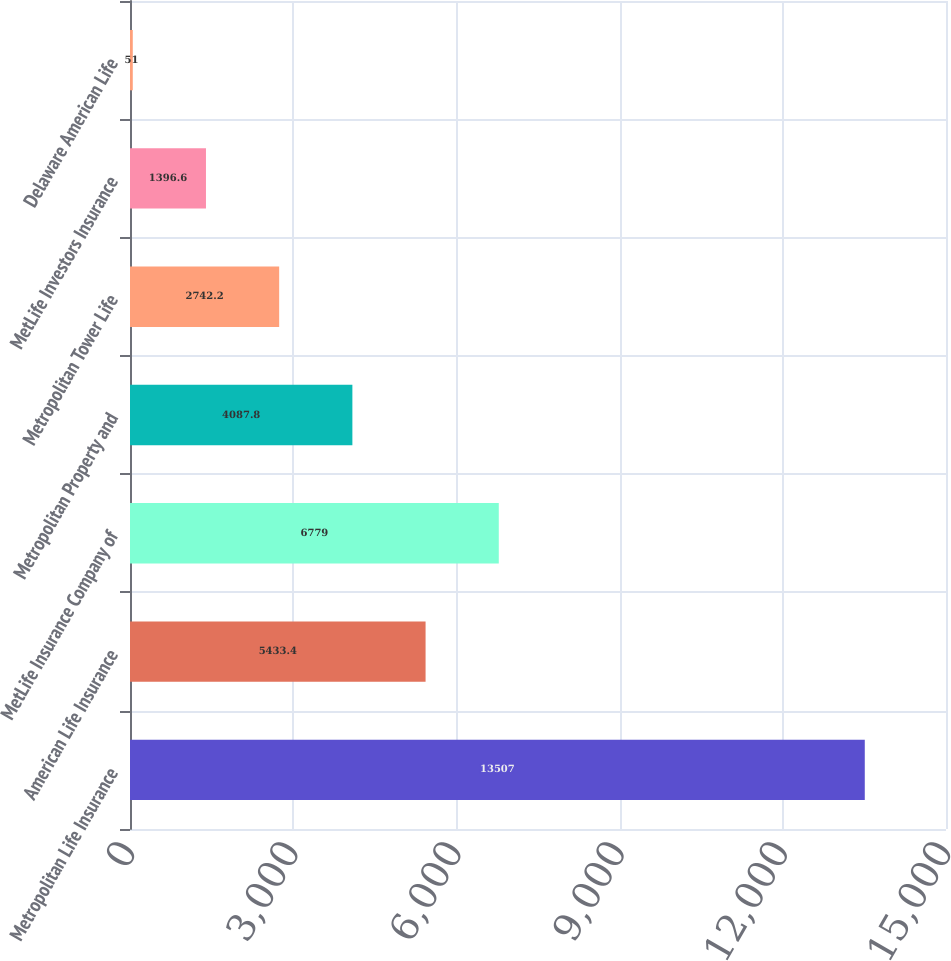Convert chart to OTSL. <chart><loc_0><loc_0><loc_500><loc_500><bar_chart><fcel>Metropolitan Life Insurance<fcel>American Life Insurance<fcel>MetLife Insurance Company of<fcel>Metropolitan Property and<fcel>Metropolitan Tower Life<fcel>MetLife Investors Insurance<fcel>Delaware American Life<nl><fcel>13507<fcel>5433.4<fcel>6779<fcel>4087.8<fcel>2742.2<fcel>1396.6<fcel>51<nl></chart> 